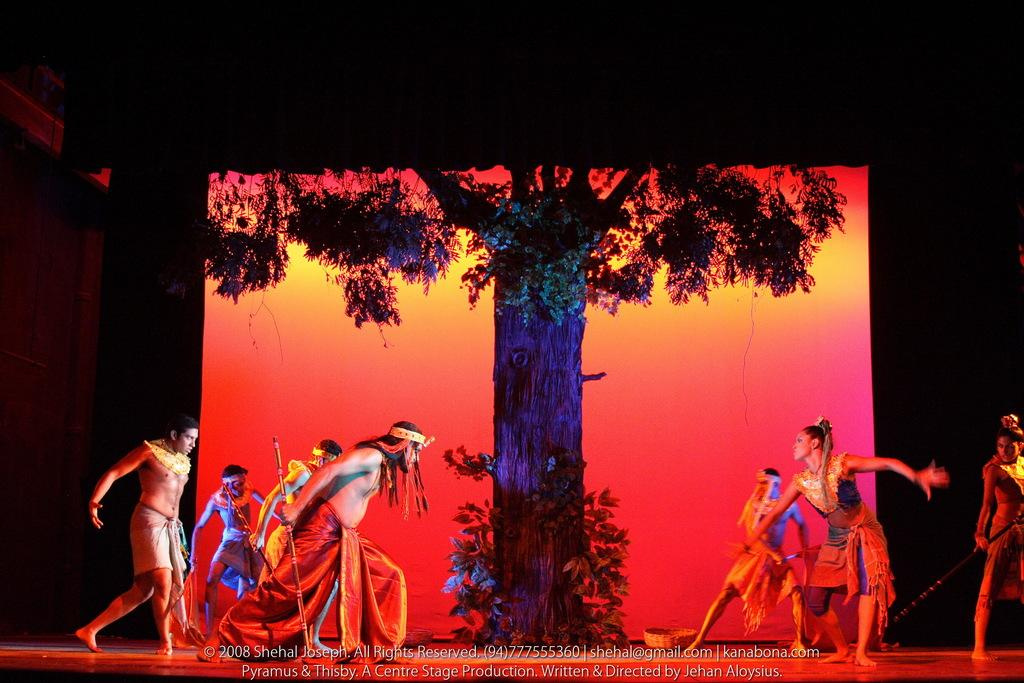Who or what is present in the image? There are people in the image. What natural element can be seen in the image? There is a tree in the image. What is the color of the background in the image? The background of the image is dark. What type of crime is being committed in the image? There is no indication of any crime being committed in the image. Where is the office located in the image? There is no office present in the image. 